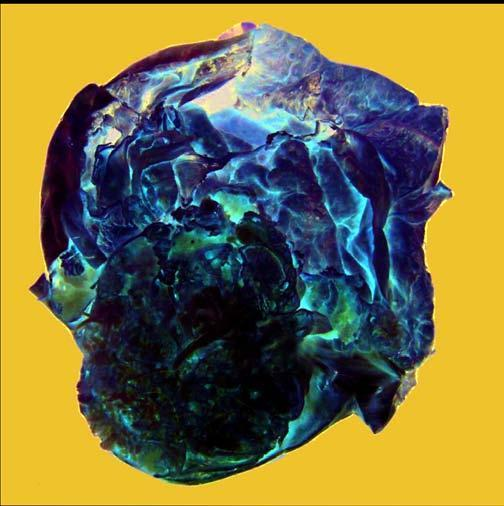what does the cyst wall show?
Answer the question using a single word or phrase. Presence of loculi containing gelatinous mucoid material 